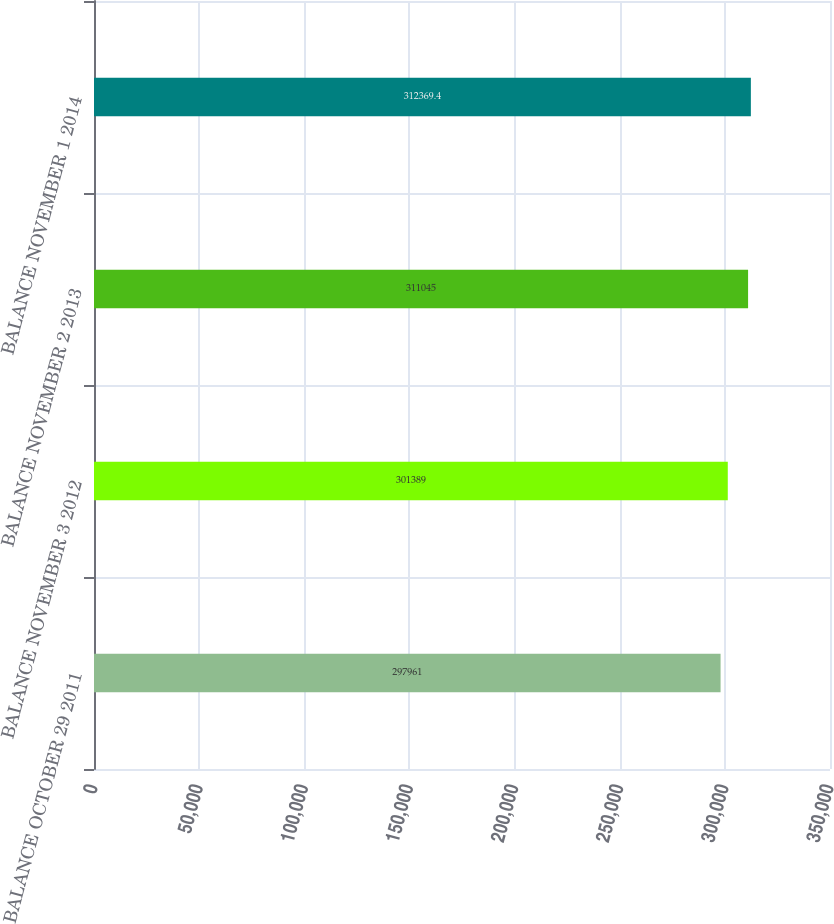Convert chart to OTSL. <chart><loc_0><loc_0><loc_500><loc_500><bar_chart><fcel>BALANCE OCTOBER 29 2011<fcel>BALANCE NOVEMBER 3 2012<fcel>BALANCE NOVEMBER 2 2013<fcel>BALANCE NOVEMBER 1 2014<nl><fcel>297961<fcel>301389<fcel>311045<fcel>312369<nl></chart> 